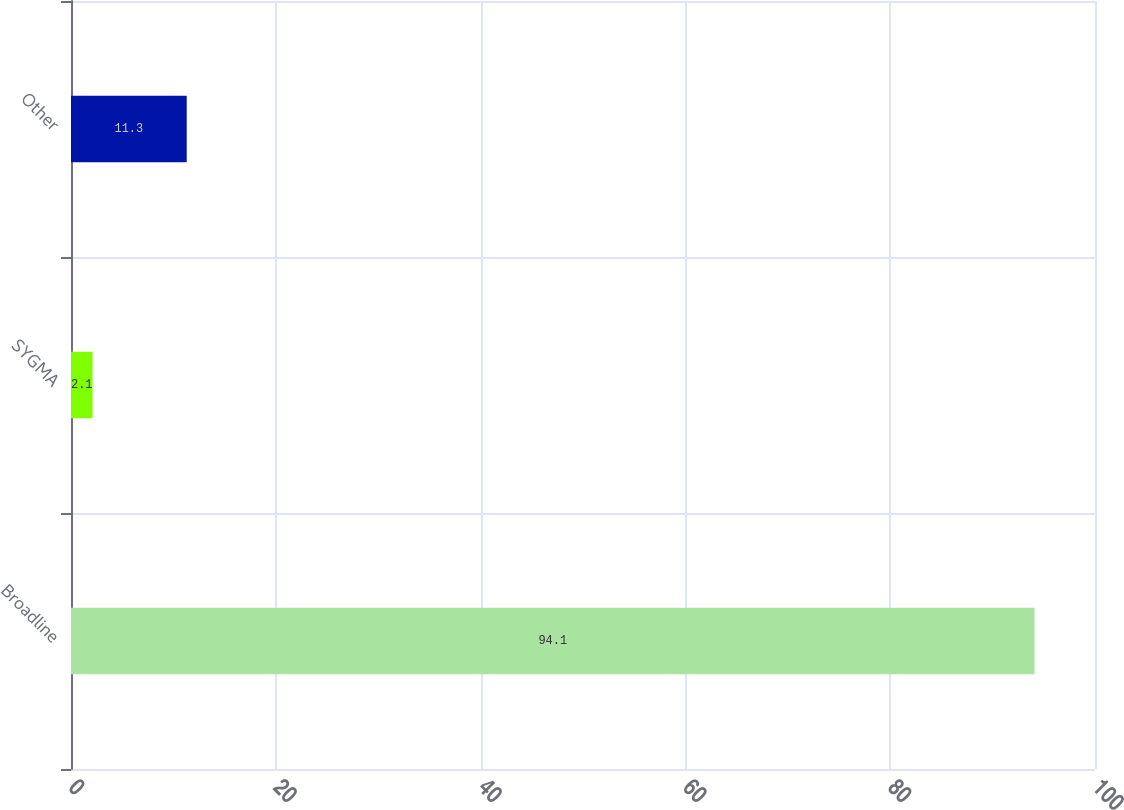<chart> <loc_0><loc_0><loc_500><loc_500><bar_chart><fcel>Broadline<fcel>SYGMA<fcel>Other<nl><fcel>94.1<fcel>2.1<fcel>11.3<nl></chart> 